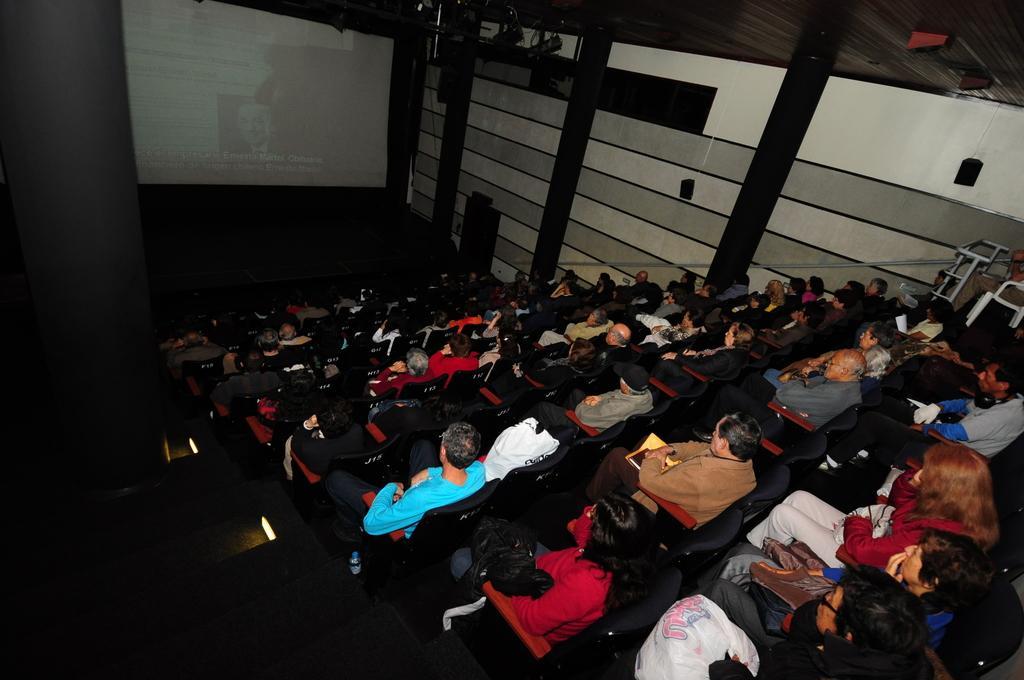How would you summarize this image in a sentence or two? In this picture we can see some people sitting on chairs, we can see a screen in the background, there is a speaker here. 